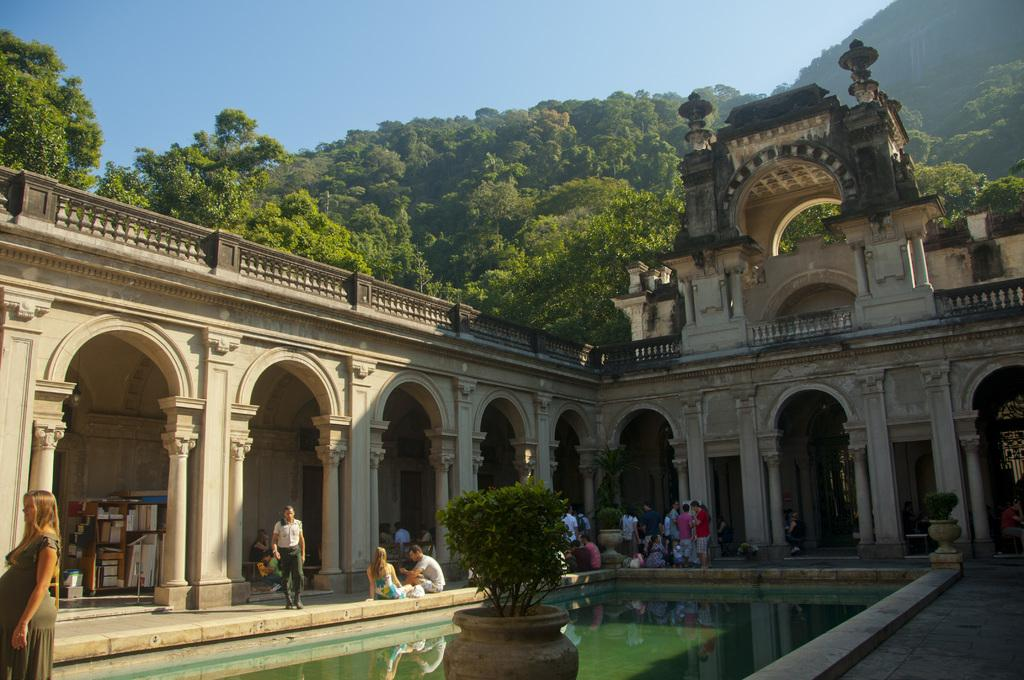What are the people in the image doing? There are persons sitting and standing in the image. What can be seen in the image besides the people? There is a plant, water, a building, trees, mountains, and the sky visible in the image. What type of grape is being washed by the team in the image? There is no grape or team present in the image. What activity is the team performing with the grape in the image? There is no grape or team present in the image, so no such activity can be observed. 